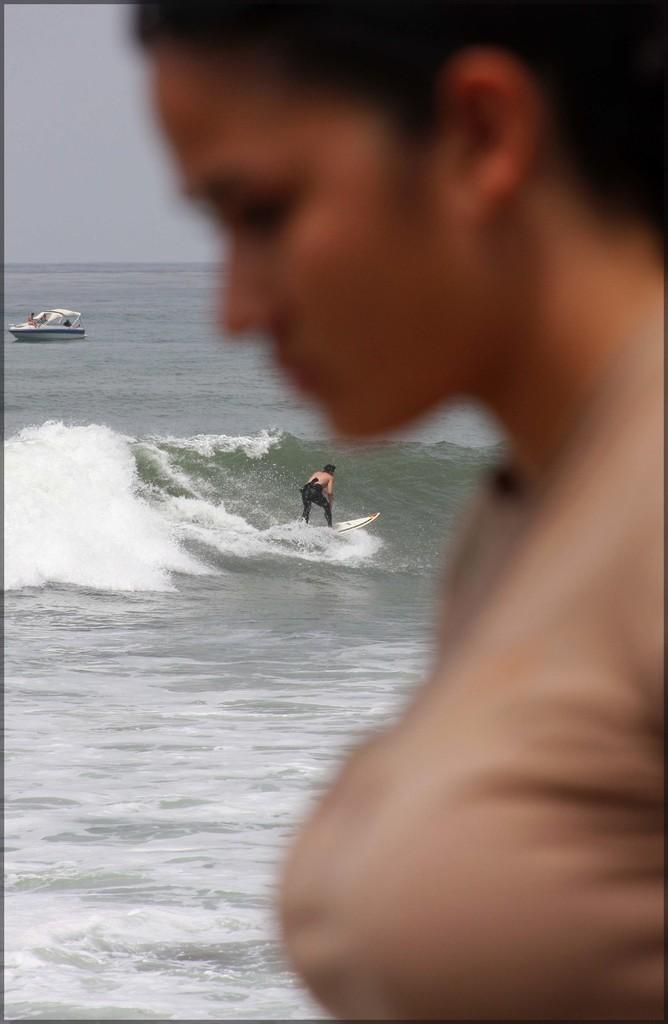Where is the woman located in the image? The woman is in the right corner of the image. What activity is being performed by the person in the image? The person is surfing in the water. How close is the person surfing to the woman? The person surfing is beside the woman. What else can be seen in the right corner of the image? There is a boat on the water in the right corner of the image. What type of flame can be seen coming from the eggnog in the image? There is no eggnog or flame present in the image. How does the sink affect the surfing activity in the image? There is no sink present in the image, so it does not affect the surfing activity. 